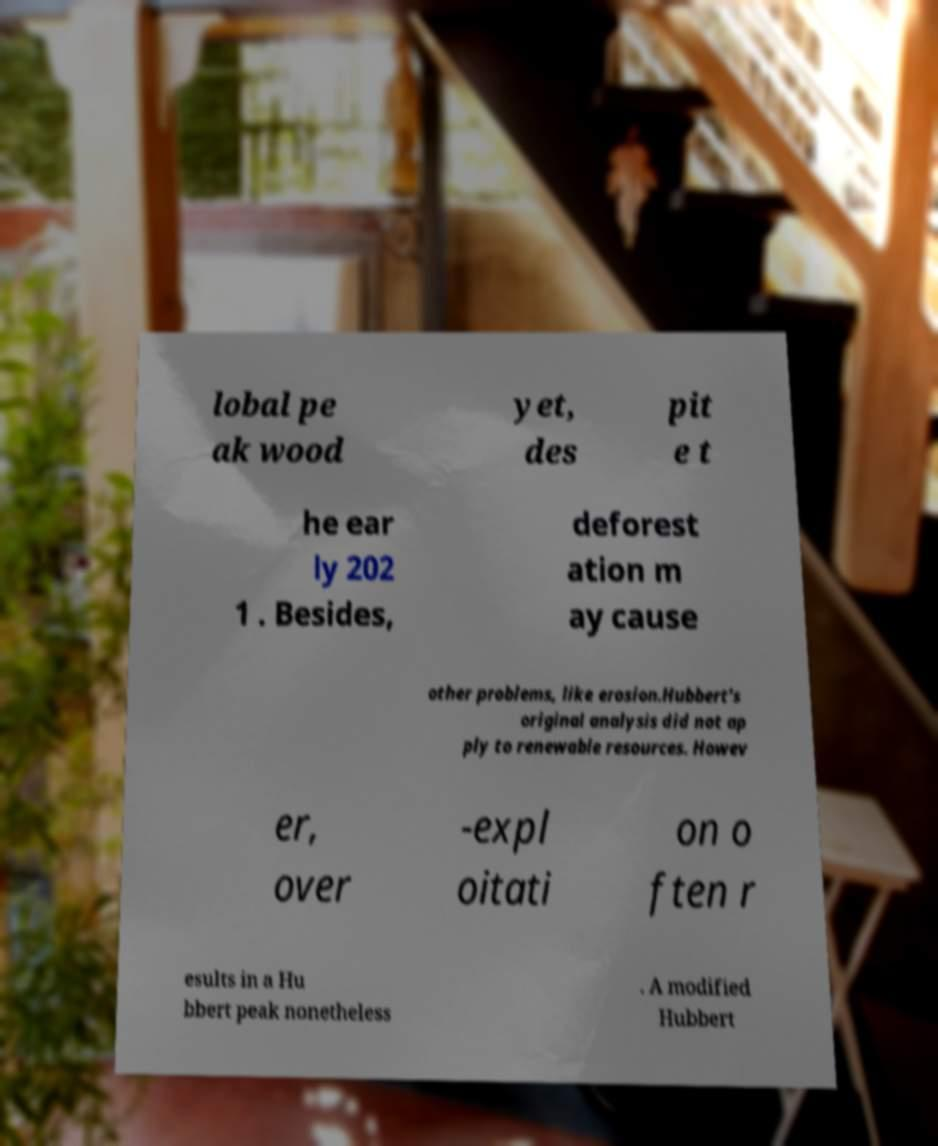Could you extract and type out the text from this image? lobal pe ak wood yet, des pit e t he ear ly 202 1 . Besides, deforest ation m ay cause other problems, like erosion.Hubbert's original analysis did not ap ply to renewable resources. Howev er, over -expl oitati on o ften r esults in a Hu bbert peak nonetheless . A modified Hubbert 